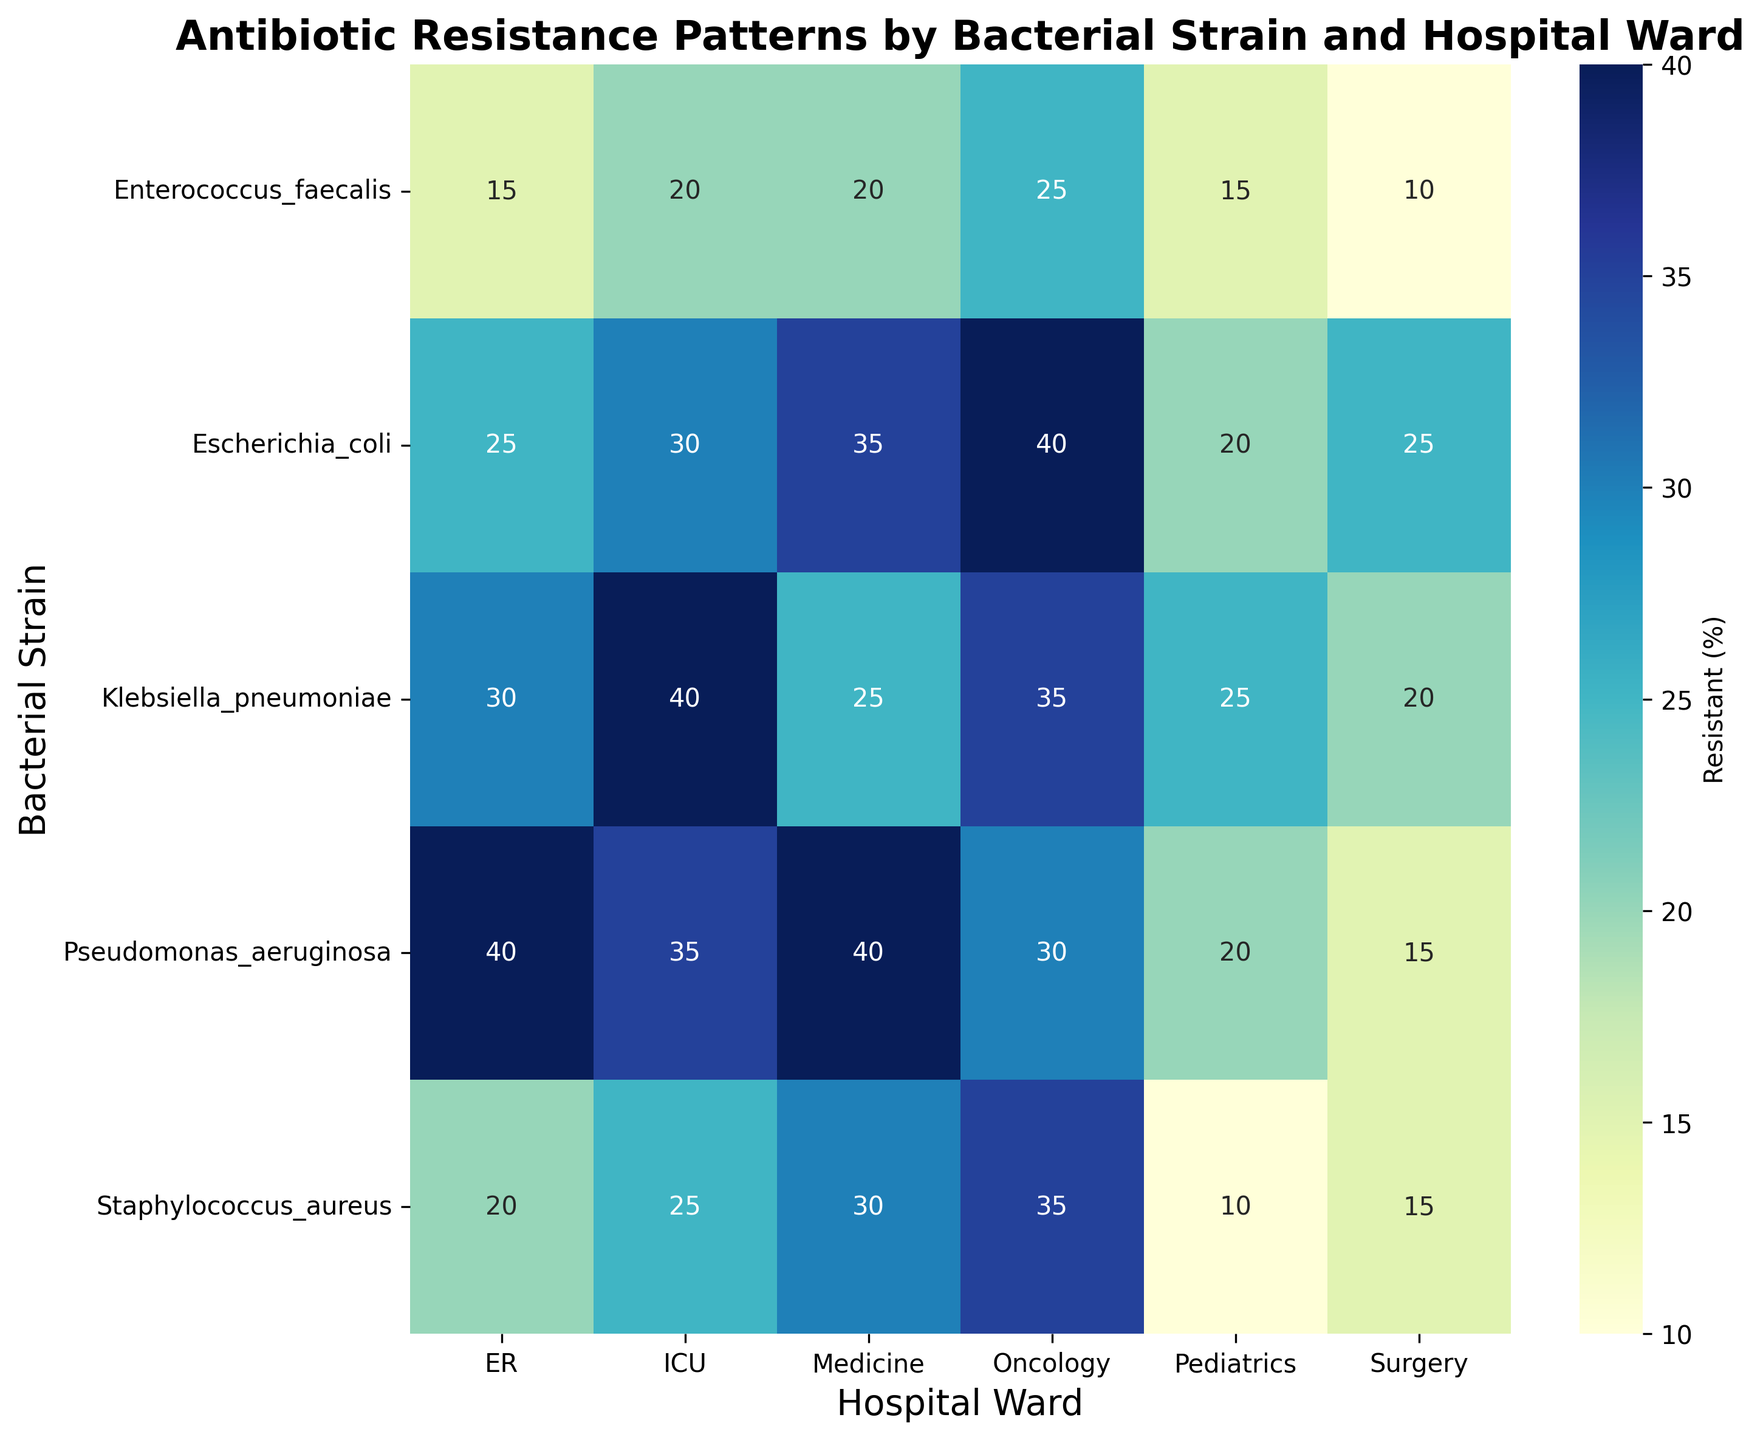Which hospital ward has the highest antibiotic resistance for Staphylococcus_aureus? To determine this, look at the heatmap values for the "Resistant" category corresponding to Staphylococcus_aureus across all wards. The highest value is found in the Oncology ward with 35%.
Answer: Oncology Is the antibiotic resistance for Escherichia_coli higher in the ICU or Surgery ward? Compare the resistant percentages of Escherichia_coli in ICU and Surgery. ICU has 30%, and Surgery has 25%. Therefore, the resistance is higher in the ICU.
Answer: ICU Which bacterial strain has the lowest resistance level in the Pediatrics ward? Look at all the resistance values in the Pediatrics ward. The lowest value is for Staphylococcus_aureus, at 10%.
Answer: Staphylococcus_aureus What is the average resistance of Klebsiella_pneumoniae across all the wards? Add the resistance percentages of Klebsiella_pneumoniae across all wards and divide by the number of wards: (40+20+25+25+35+30)/6 = 29.17%.
Answer: 29.17% Which hospital ward has the most variation in antibiotic resistance rates across different bacterial strains? Compare the range (difference between maximum and minimum values) of antibiotic resistance percentages for each ward. The ICU ranges from 20% to 40%, Surgery from 10% to 25%, Medicine from 20% to 40%, Pediatrics from 10% to 25%, Oncology from 25% to 40%, and ER from 15% to 40%. Both ICU, Medicine, and ER show the highest variation, ranging over 20%.
Answer: ICU, Medicine, ER Is the antibiotic resistance for Pseudomonas_aeruginosa greater in ICU or Oncology ward? Compare the resistant percentages for Pseudomonas_aeruginosa in the ICU and Oncology. ICU has 35%, while Oncology has 30%. Thus, ICU has higher resistance.
Answer: ICU Which bacterial strain exhibits the highest resistance in Medicine ward? Check the resistance percentages for all bacterial strains in the Medicine ward. Pseudomonas_aeruginosa has the highest resistance at 40%.
Answer: Pseudomonas_aeruginosa What is the total resistant percentage of Staphylococcus_aureus in the Pediatrics and Surgery wards combined? Add the resistance percentages of Staphylococcus_aureus in Pediatrics (10%) and Surgery (15%): 10 + 15 = 25%.
Answer: 25% How does the resistance for Enterococcus_faecalis in Pediatrics compare to that in the ER? Check the resistance percentages: Pediatrics has 15%, and the ER has 15%. Thus, they are equal.
Answer: Equal 